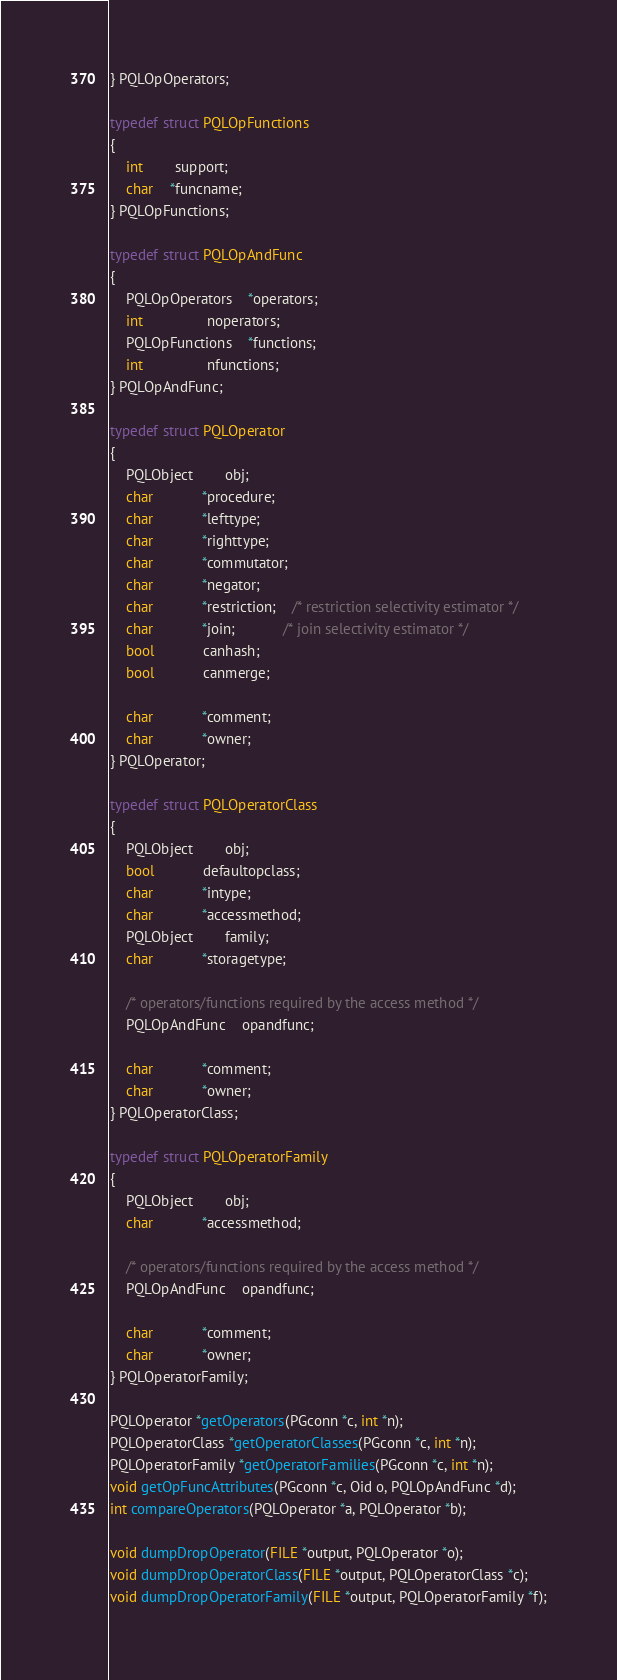Convert code to text. <code><loc_0><loc_0><loc_500><loc_500><_C_>} PQLOpOperators;

typedef struct PQLOpFunctions
{
	int		support;
	char	*funcname;
} PQLOpFunctions;

typedef struct PQLOpAndFunc
{
	PQLOpOperators	*operators;
	int				noperators;
	PQLOpFunctions	*functions;
	int				nfunctions;
} PQLOpAndFunc;

typedef struct PQLOperator
{
	PQLObject		obj;
	char			*procedure;
	char			*lefttype;
	char			*righttype;
	char			*commutator;
	char			*negator;
	char			*restriction;	/* restriction selectivity estimator */
	char			*join;			/* join selectivity estimator */
	bool			canhash;
	bool			canmerge;

	char			*comment;
	char			*owner;
} PQLOperator;

typedef struct PQLOperatorClass
{
	PQLObject		obj;
	bool			defaultopclass;
	char			*intype;
	char			*accessmethod;
	PQLObject		family;
	char			*storagetype;

	/* operators/functions required by the access method */
	PQLOpAndFunc	opandfunc;

	char			*comment;
	char			*owner;
} PQLOperatorClass;

typedef struct PQLOperatorFamily
{
	PQLObject		obj;
	char			*accessmethod;

	/* operators/functions required by the access method */
	PQLOpAndFunc	opandfunc;

	char			*comment;
	char			*owner;
} PQLOperatorFamily;

PQLOperator *getOperators(PGconn *c, int *n);
PQLOperatorClass *getOperatorClasses(PGconn *c, int *n);
PQLOperatorFamily *getOperatorFamilies(PGconn *c, int *n);
void getOpFuncAttributes(PGconn *c, Oid o, PQLOpAndFunc *d);
int compareOperators(PQLOperator *a, PQLOperator *b);

void dumpDropOperator(FILE *output, PQLOperator *o);
void dumpDropOperatorClass(FILE *output, PQLOperatorClass *c);
void dumpDropOperatorFamily(FILE *output, PQLOperatorFamily *f);</code> 